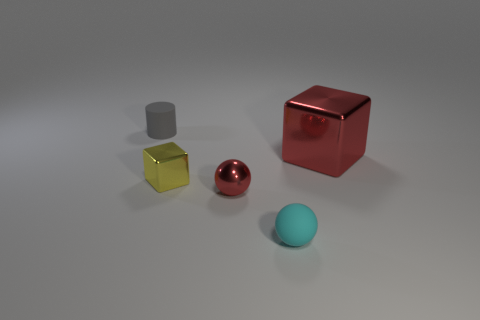Add 2 gray rubber cylinders. How many objects exist? 7 Subtract all red blocks. How many blocks are left? 1 Subtract all balls. How many objects are left? 3 Add 5 big red blocks. How many big red blocks exist? 6 Subtract 0 green blocks. How many objects are left? 5 Subtract all blue cylinders. Subtract all red blocks. How many cylinders are left? 1 Subtract all cyan balls. How many purple cubes are left? 0 Subtract all tiny rubber balls. Subtract all metal objects. How many objects are left? 1 Add 4 spheres. How many spheres are left? 6 